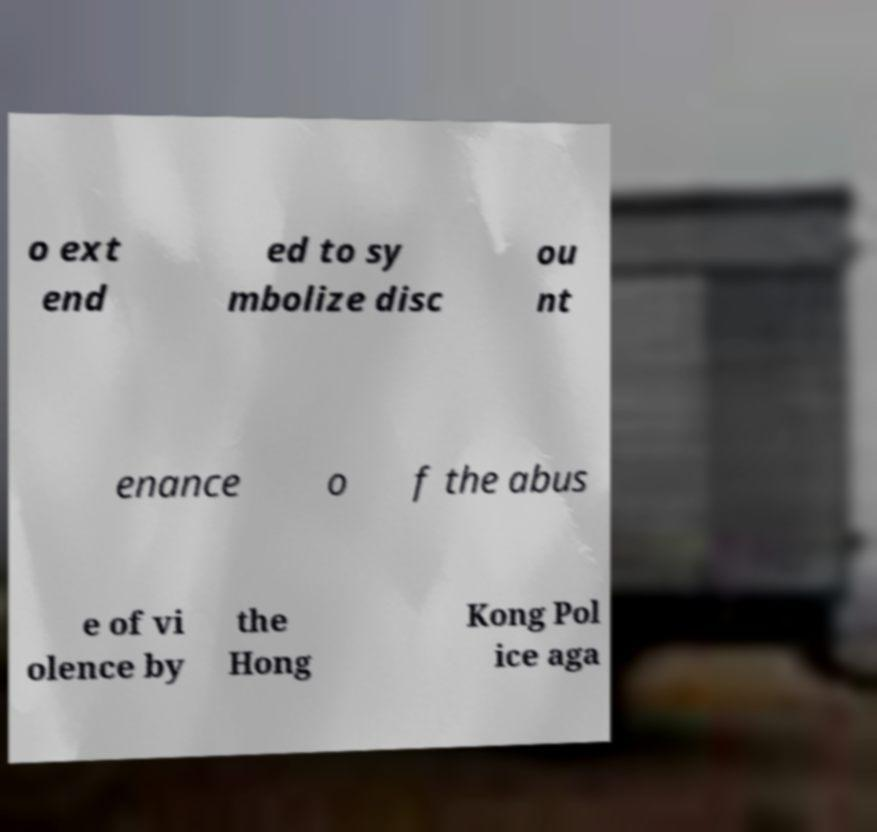Can you accurately transcribe the text from the provided image for me? o ext end ed to sy mbolize disc ou nt enance o f the abus e of vi olence by the Hong Kong Pol ice aga 